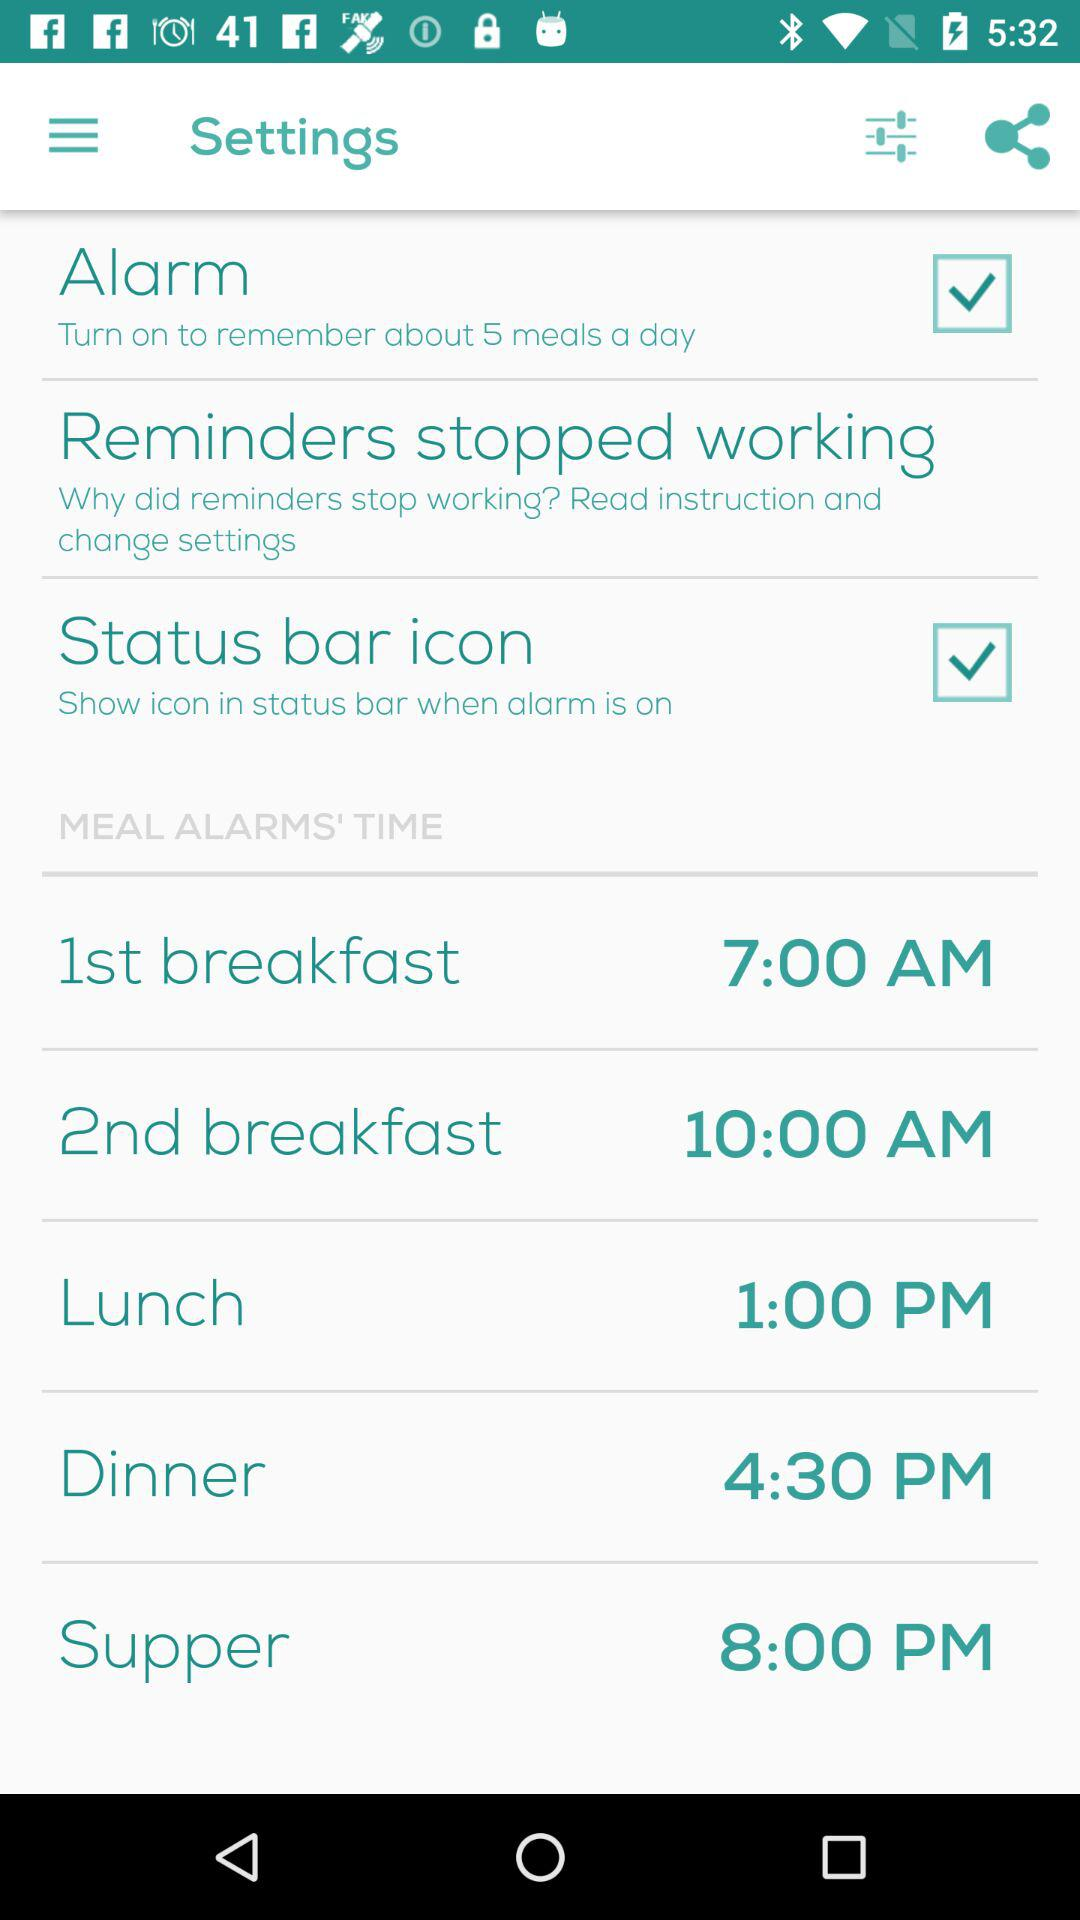What is the status of the "Alarm"? The status is "on". 